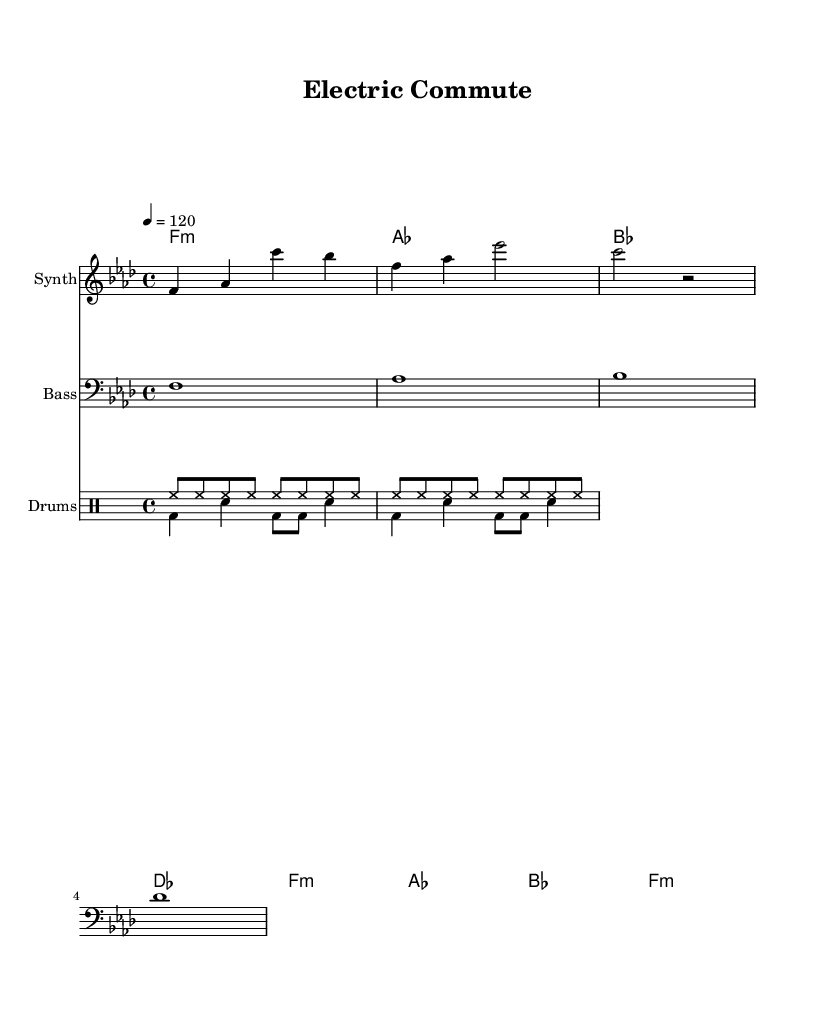What is the key signature of this music? The key signature indicates that the music is in F minor, which contains four flats (B♭, E♭, A♭, D♭). This can be identified from the notated key signature at the beginning of the score.
Answer: F minor What is the time signature of this score? The time signature displayed at the beginning of the score is 4/4, indicating that there are four beats in each measure, and the quarter note receives one beat. This can be observed from the notation right after the key signature.
Answer: 4/4 What is the tempo marking for this piece? The tempo marking shows "4 = 120", meaning that a quarter note equals 120 beats per minute. This information is located next to the time signature, indicating the speed of the piece.
Answer: 120 What is the instrument used for the melody? The melody is notated for the "Synth," which is specified at the beginning of the staff where the melody is written. This helps to clarify the timbre associated with the melody line.
Answer: Synth How many measures does the score contain? The score contains a total of 4 measures, which can be counted based on the measures indicated by vertical lines separating the rhythmic groups in the melody.
Answer: 4 What type of drum pattern is primarily used? The drum patterns include hi-hat variations and kick and snare rhythms, typical of house music, showcased in the drum staff. The presence of the hi-hat plays a consistent pattern, while the kick and snare create a more dynamic rhythmic feel.
Answer: Hi-hat variations Which chord is used as the first harmony? The first harmony in the chordal progression is F minor, as indicated by the chord symbol at the beginning of the first measure of the harmonies. This symbolizes the underlying harmonic structure for the initial part of the piece.
Answer: F minor 